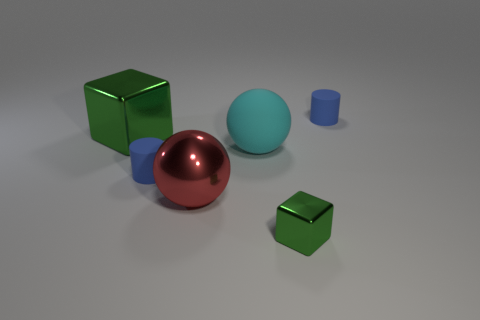Add 1 large cyan metallic objects. How many objects exist? 7 Subtract all balls. How many objects are left? 4 Subtract all cyan blocks. Subtract all red cylinders. How many blocks are left? 2 Subtract all small rubber cylinders. Subtract all metallic cubes. How many objects are left? 2 Add 3 rubber spheres. How many rubber spheres are left? 4 Add 5 tiny metal things. How many tiny metal things exist? 6 Subtract 0 purple spheres. How many objects are left? 6 